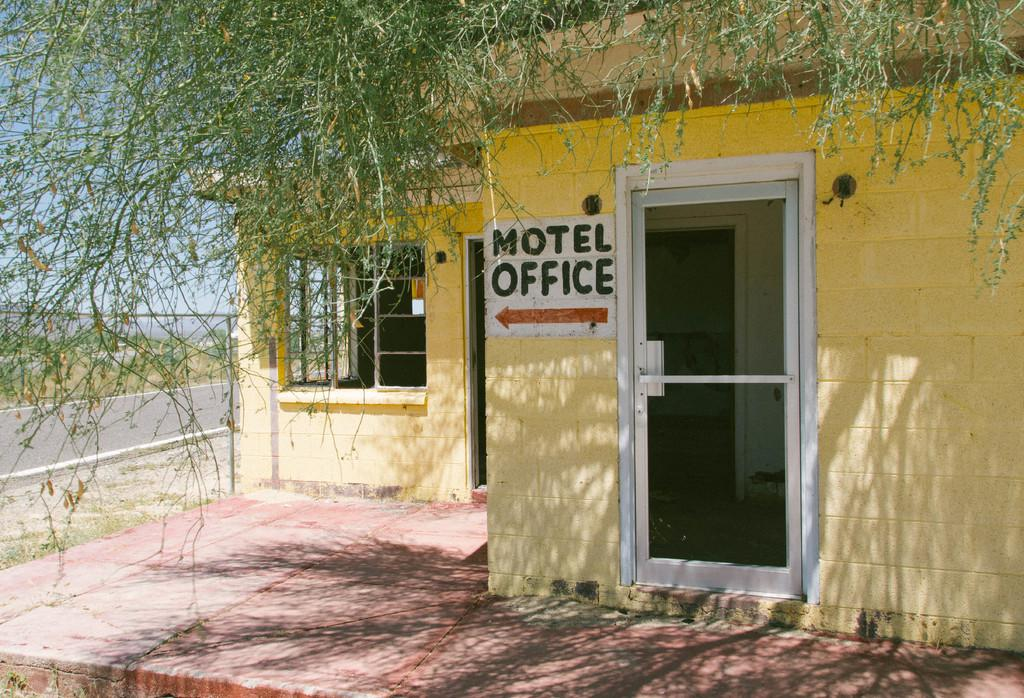What is the main structure in the foreground of the image? There is a building in the foreground of the image. What can be seen at the top of the image? There appears to be a tree at the top of the image. What is visible in the background of the image? There is a road and the sky visible in the background of the image. How many friends are sitting on the coat in the image? There is no coat or friends present in the image. 